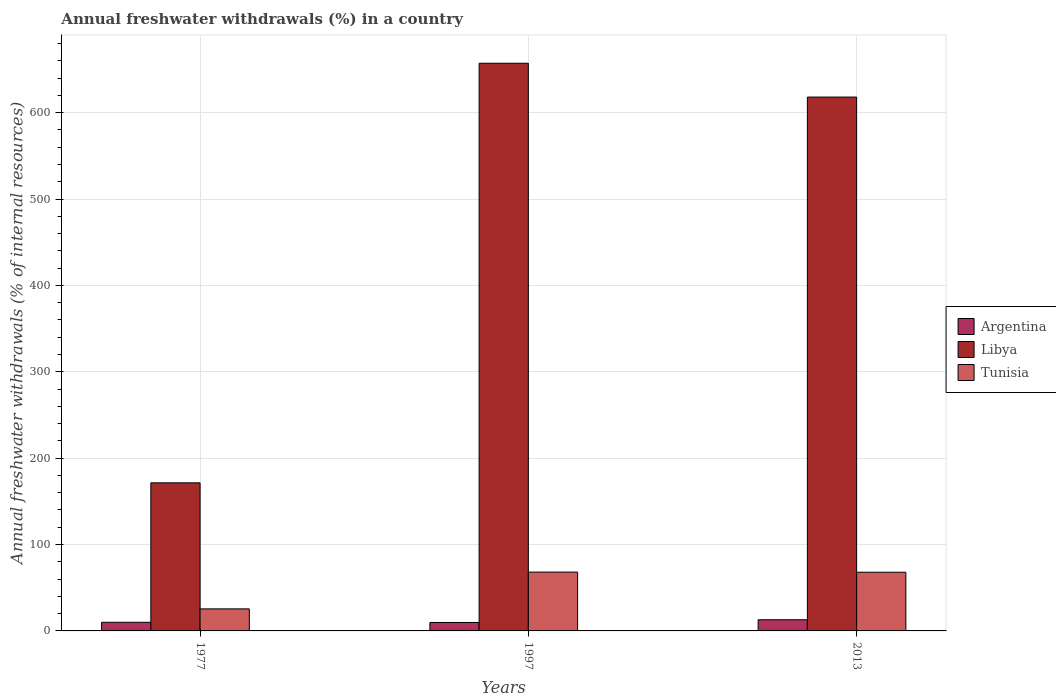Are the number of bars per tick equal to the number of legend labels?
Provide a short and direct response. Yes. What is the label of the 1st group of bars from the left?
Give a very brief answer. 1977. In how many cases, is the number of bars for a given year not equal to the number of legend labels?
Keep it short and to the point. 0. What is the percentage of annual freshwater withdrawals in Libya in 1977?
Offer a terse response. 171.43. Across all years, what is the maximum percentage of annual freshwater withdrawals in Libya?
Your answer should be very brief. 657.14. Across all years, what is the minimum percentage of annual freshwater withdrawals in Tunisia?
Provide a succinct answer. 25.51. What is the total percentage of annual freshwater withdrawals in Libya in the graph?
Offer a very short reply. 1446.57. What is the difference between the percentage of annual freshwater withdrawals in Argentina in 1977 and that in 2013?
Offer a terse response. -2.94. What is the difference between the percentage of annual freshwater withdrawals in Argentina in 1997 and the percentage of annual freshwater withdrawals in Libya in 2013?
Your answer should be very brief. -608.21. What is the average percentage of annual freshwater withdrawals in Argentina per year?
Provide a short and direct response. 10.91. In the year 1977, what is the difference between the percentage of annual freshwater withdrawals in Tunisia and percentage of annual freshwater withdrawals in Libya?
Provide a succinct answer. -145.92. In how many years, is the percentage of annual freshwater withdrawals in Tunisia greater than 160 %?
Your answer should be compact. 0. What is the ratio of the percentage of annual freshwater withdrawals in Tunisia in 1977 to that in 1997?
Keep it short and to the point. 0.37. Is the difference between the percentage of annual freshwater withdrawals in Tunisia in 1977 and 2013 greater than the difference between the percentage of annual freshwater withdrawals in Libya in 1977 and 2013?
Your answer should be compact. Yes. What is the difference between the highest and the second highest percentage of annual freshwater withdrawals in Libya?
Your answer should be compact. 39.14. What is the difference between the highest and the lowest percentage of annual freshwater withdrawals in Libya?
Keep it short and to the point. 485.71. In how many years, is the percentage of annual freshwater withdrawals in Tunisia greater than the average percentage of annual freshwater withdrawals in Tunisia taken over all years?
Your answer should be compact. 2. Is the sum of the percentage of annual freshwater withdrawals in Argentina in 1977 and 2013 greater than the maximum percentage of annual freshwater withdrawals in Libya across all years?
Offer a terse response. No. What does the 3rd bar from the left in 2013 represents?
Give a very brief answer. Tunisia. What does the 2nd bar from the right in 2013 represents?
Provide a succinct answer. Libya. Is it the case that in every year, the sum of the percentage of annual freshwater withdrawals in Argentina and percentage of annual freshwater withdrawals in Libya is greater than the percentage of annual freshwater withdrawals in Tunisia?
Offer a terse response. Yes. How many bars are there?
Keep it short and to the point. 9. How many years are there in the graph?
Ensure brevity in your answer.  3. Does the graph contain any zero values?
Your answer should be very brief. No. Does the graph contain grids?
Your response must be concise. Yes. Where does the legend appear in the graph?
Keep it short and to the point. Center right. What is the title of the graph?
Your answer should be very brief. Annual freshwater withdrawals (%) in a country. What is the label or title of the X-axis?
Offer a terse response. Years. What is the label or title of the Y-axis?
Your response must be concise. Annual freshwater withdrawals (% of internal resources). What is the Annual freshwater withdrawals (% of internal resources) of Argentina in 1977?
Your answer should be compact. 10. What is the Annual freshwater withdrawals (% of internal resources) of Libya in 1977?
Offer a terse response. 171.43. What is the Annual freshwater withdrawals (% of internal resources) of Tunisia in 1977?
Make the answer very short. 25.51. What is the Annual freshwater withdrawals (% of internal resources) in Argentina in 1997?
Give a very brief answer. 9.79. What is the Annual freshwater withdrawals (% of internal resources) of Libya in 1997?
Provide a short and direct response. 657.14. What is the Annual freshwater withdrawals (% of internal resources) of Tunisia in 1997?
Your answer should be very brief. 68.1. What is the Annual freshwater withdrawals (% of internal resources) in Argentina in 2013?
Offer a terse response. 12.94. What is the Annual freshwater withdrawals (% of internal resources) of Libya in 2013?
Your response must be concise. 618. What is the Annual freshwater withdrawals (% of internal resources) in Tunisia in 2013?
Your response must be concise. 67.94. Across all years, what is the maximum Annual freshwater withdrawals (% of internal resources) in Argentina?
Provide a short and direct response. 12.94. Across all years, what is the maximum Annual freshwater withdrawals (% of internal resources) of Libya?
Provide a short and direct response. 657.14. Across all years, what is the maximum Annual freshwater withdrawals (% of internal resources) in Tunisia?
Your response must be concise. 68.1. Across all years, what is the minimum Annual freshwater withdrawals (% of internal resources) in Argentina?
Give a very brief answer. 9.79. Across all years, what is the minimum Annual freshwater withdrawals (% of internal resources) of Libya?
Give a very brief answer. 171.43. Across all years, what is the minimum Annual freshwater withdrawals (% of internal resources) in Tunisia?
Keep it short and to the point. 25.51. What is the total Annual freshwater withdrawals (% of internal resources) in Argentina in the graph?
Ensure brevity in your answer.  32.73. What is the total Annual freshwater withdrawals (% of internal resources) of Libya in the graph?
Keep it short and to the point. 1446.57. What is the total Annual freshwater withdrawals (% of internal resources) in Tunisia in the graph?
Offer a very short reply. 161.55. What is the difference between the Annual freshwater withdrawals (% of internal resources) in Argentina in 1977 and that in 1997?
Make the answer very short. 0.21. What is the difference between the Annual freshwater withdrawals (% of internal resources) in Libya in 1977 and that in 1997?
Provide a short and direct response. -485.71. What is the difference between the Annual freshwater withdrawals (% of internal resources) in Tunisia in 1977 and that in 1997?
Your answer should be very brief. -42.6. What is the difference between the Annual freshwater withdrawals (% of internal resources) in Argentina in 1977 and that in 2013?
Give a very brief answer. -2.94. What is the difference between the Annual freshwater withdrawals (% of internal resources) in Libya in 1977 and that in 2013?
Provide a succinct answer. -446.57. What is the difference between the Annual freshwater withdrawals (% of internal resources) in Tunisia in 1977 and that in 2013?
Your answer should be compact. -42.43. What is the difference between the Annual freshwater withdrawals (% of internal resources) in Argentina in 1997 and that in 2013?
Offer a very short reply. -3.15. What is the difference between the Annual freshwater withdrawals (% of internal resources) in Libya in 1997 and that in 2013?
Ensure brevity in your answer.  39.14. What is the difference between the Annual freshwater withdrawals (% of internal resources) of Tunisia in 1997 and that in 2013?
Give a very brief answer. 0.17. What is the difference between the Annual freshwater withdrawals (% of internal resources) of Argentina in 1977 and the Annual freshwater withdrawals (% of internal resources) of Libya in 1997?
Your answer should be compact. -647.14. What is the difference between the Annual freshwater withdrawals (% of internal resources) in Argentina in 1977 and the Annual freshwater withdrawals (% of internal resources) in Tunisia in 1997?
Provide a short and direct response. -58.1. What is the difference between the Annual freshwater withdrawals (% of internal resources) in Libya in 1977 and the Annual freshwater withdrawals (% of internal resources) in Tunisia in 1997?
Keep it short and to the point. 103.32. What is the difference between the Annual freshwater withdrawals (% of internal resources) of Argentina in 1977 and the Annual freshwater withdrawals (% of internal resources) of Libya in 2013?
Offer a terse response. -608. What is the difference between the Annual freshwater withdrawals (% of internal resources) in Argentina in 1977 and the Annual freshwater withdrawals (% of internal resources) in Tunisia in 2013?
Provide a succinct answer. -57.94. What is the difference between the Annual freshwater withdrawals (% of internal resources) of Libya in 1977 and the Annual freshwater withdrawals (% of internal resources) of Tunisia in 2013?
Provide a short and direct response. 103.49. What is the difference between the Annual freshwater withdrawals (% of internal resources) of Argentina in 1997 and the Annual freshwater withdrawals (% of internal resources) of Libya in 2013?
Make the answer very short. -608.21. What is the difference between the Annual freshwater withdrawals (% of internal resources) of Argentina in 1997 and the Annual freshwater withdrawals (% of internal resources) of Tunisia in 2013?
Give a very brief answer. -58.15. What is the difference between the Annual freshwater withdrawals (% of internal resources) in Libya in 1997 and the Annual freshwater withdrawals (% of internal resources) in Tunisia in 2013?
Offer a terse response. 589.2. What is the average Annual freshwater withdrawals (% of internal resources) of Argentina per year?
Give a very brief answer. 10.91. What is the average Annual freshwater withdrawals (% of internal resources) in Libya per year?
Give a very brief answer. 482.19. What is the average Annual freshwater withdrawals (% of internal resources) in Tunisia per year?
Provide a short and direct response. 53.85. In the year 1977, what is the difference between the Annual freshwater withdrawals (% of internal resources) in Argentina and Annual freshwater withdrawals (% of internal resources) in Libya?
Make the answer very short. -161.43. In the year 1977, what is the difference between the Annual freshwater withdrawals (% of internal resources) of Argentina and Annual freshwater withdrawals (% of internal resources) of Tunisia?
Provide a succinct answer. -15.51. In the year 1977, what is the difference between the Annual freshwater withdrawals (% of internal resources) in Libya and Annual freshwater withdrawals (% of internal resources) in Tunisia?
Your response must be concise. 145.92. In the year 1997, what is the difference between the Annual freshwater withdrawals (% of internal resources) of Argentina and Annual freshwater withdrawals (% of internal resources) of Libya?
Provide a succinct answer. -647.36. In the year 1997, what is the difference between the Annual freshwater withdrawals (% of internal resources) in Argentina and Annual freshwater withdrawals (% of internal resources) in Tunisia?
Make the answer very short. -58.32. In the year 1997, what is the difference between the Annual freshwater withdrawals (% of internal resources) of Libya and Annual freshwater withdrawals (% of internal resources) of Tunisia?
Offer a terse response. 589.04. In the year 2013, what is the difference between the Annual freshwater withdrawals (% of internal resources) of Argentina and Annual freshwater withdrawals (% of internal resources) of Libya?
Give a very brief answer. -605.06. In the year 2013, what is the difference between the Annual freshwater withdrawals (% of internal resources) of Argentina and Annual freshwater withdrawals (% of internal resources) of Tunisia?
Give a very brief answer. -55. In the year 2013, what is the difference between the Annual freshwater withdrawals (% of internal resources) of Libya and Annual freshwater withdrawals (% of internal resources) of Tunisia?
Your answer should be compact. 550.06. What is the ratio of the Annual freshwater withdrawals (% of internal resources) of Argentina in 1977 to that in 1997?
Give a very brief answer. 1.02. What is the ratio of the Annual freshwater withdrawals (% of internal resources) of Libya in 1977 to that in 1997?
Offer a terse response. 0.26. What is the ratio of the Annual freshwater withdrawals (% of internal resources) in Tunisia in 1977 to that in 1997?
Make the answer very short. 0.37. What is the ratio of the Annual freshwater withdrawals (% of internal resources) of Argentina in 1977 to that in 2013?
Offer a terse response. 0.77. What is the ratio of the Annual freshwater withdrawals (% of internal resources) of Libya in 1977 to that in 2013?
Provide a short and direct response. 0.28. What is the ratio of the Annual freshwater withdrawals (% of internal resources) in Tunisia in 1977 to that in 2013?
Provide a succinct answer. 0.38. What is the ratio of the Annual freshwater withdrawals (% of internal resources) of Argentina in 1997 to that in 2013?
Provide a succinct answer. 0.76. What is the ratio of the Annual freshwater withdrawals (% of internal resources) of Libya in 1997 to that in 2013?
Your answer should be very brief. 1.06. What is the difference between the highest and the second highest Annual freshwater withdrawals (% of internal resources) of Argentina?
Your response must be concise. 2.94. What is the difference between the highest and the second highest Annual freshwater withdrawals (% of internal resources) of Libya?
Your answer should be compact. 39.14. What is the difference between the highest and the second highest Annual freshwater withdrawals (% of internal resources) of Tunisia?
Keep it short and to the point. 0.17. What is the difference between the highest and the lowest Annual freshwater withdrawals (% of internal resources) of Argentina?
Make the answer very short. 3.15. What is the difference between the highest and the lowest Annual freshwater withdrawals (% of internal resources) in Libya?
Your answer should be very brief. 485.71. What is the difference between the highest and the lowest Annual freshwater withdrawals (% of internal resources) in Tunisia?
Provide a short and direct response. 42.6. 